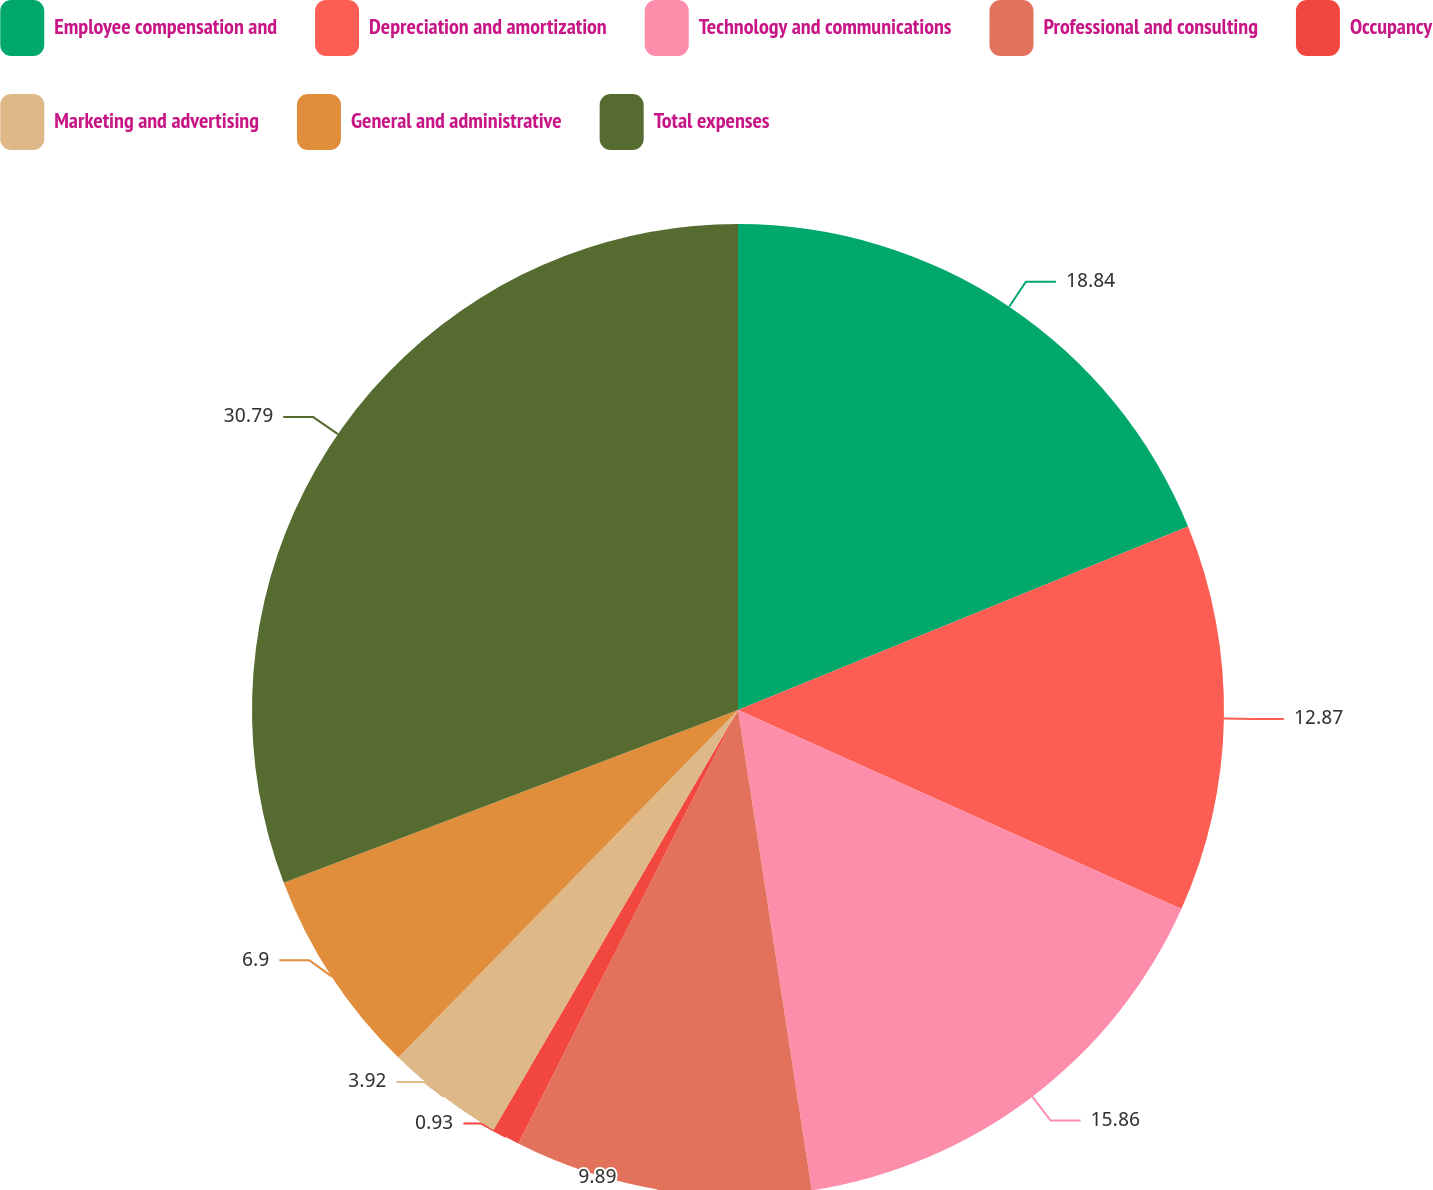Convert chart. <chart><loc_0><loc_0><loc_500><loc_500><pie_chart><fcel>Employee compensation and<fcel>Depreciation and amortization<fcel>Technology and communications<fcel>Professional and consulting<fcel>Occupancy<fcel>Marketing and advertising<fcel>General and administrative<fcel>Total expenses<nl><fcel>18.84%<fcel>12.87%<fcel>15.86%<fcel>9.89%<fcel>0.93%<fcel>3.92%<fcel>6.9%<fcel>30.78%<nl></chart> 